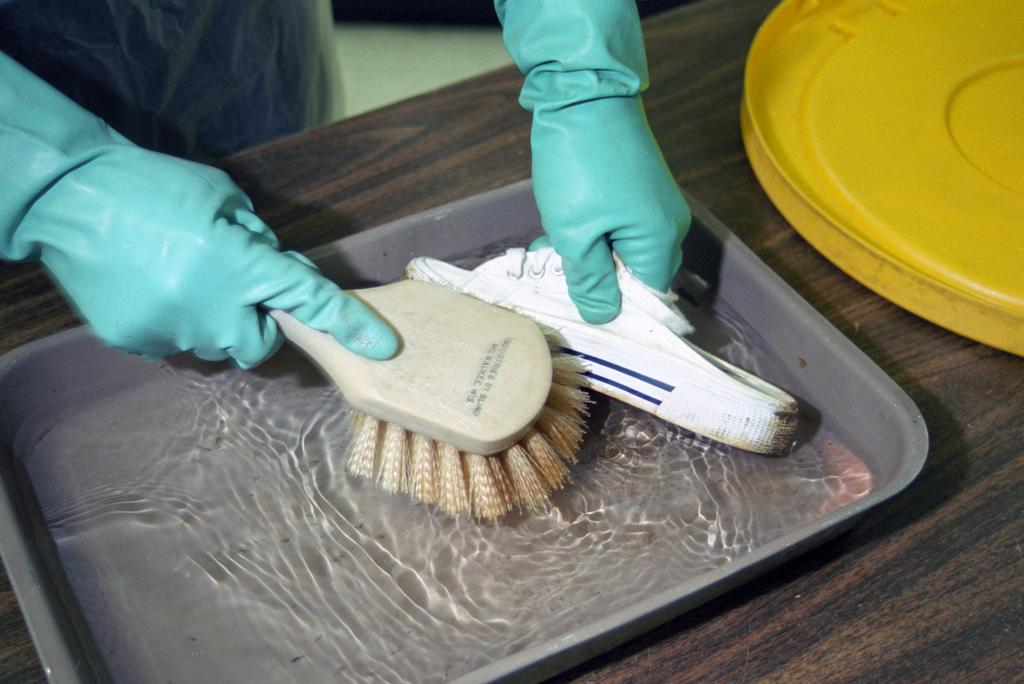What can be seen in the image? There is a person in the image. What is the person wearing on their hands? The person is wearing blue gloves. What is the person holding? The person is holding something, but we cannot determine what it is from the image. What is present in the tray in the image? There is water in a tray in the image. What color is the object on the table in the image? There is a yellow object on the table in the image. Can you see any mountains in the image? No, there are no mountains present in the image. How much sugar is in the water in the tray? There is no sugar mentioned or visible in the image; it only shows water in a tray. 